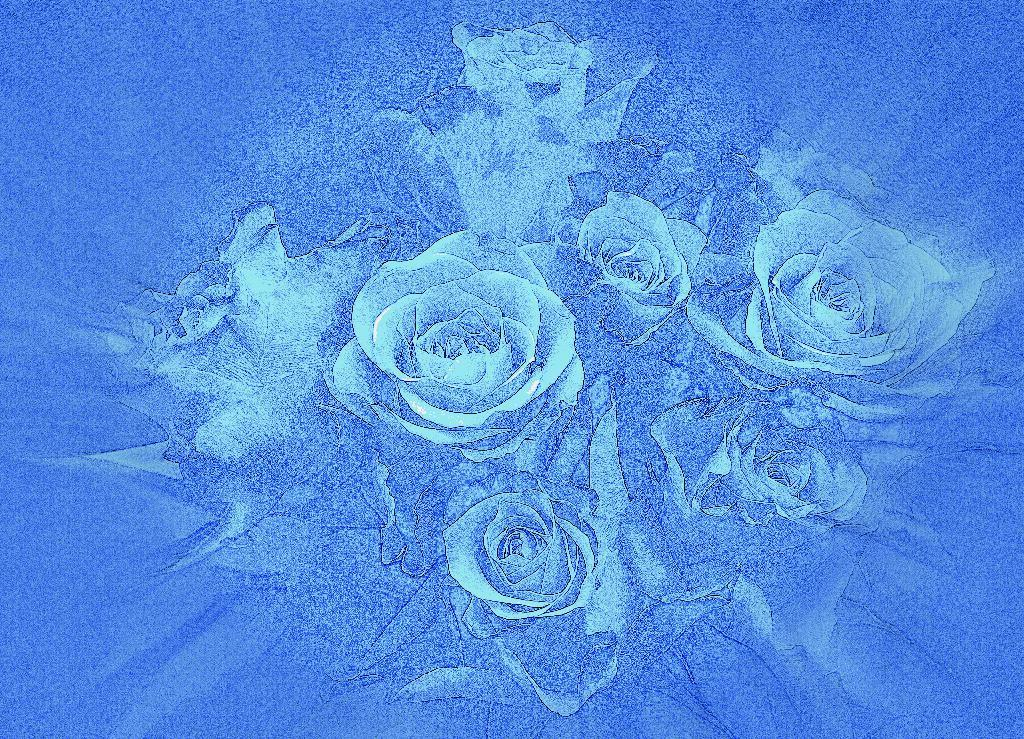What type of image is this? The image is an edited version. What is the main subject of the image? The image depicts roses. What is unique about the roses in the image? The roses are in blue color. What theory does the man in the image propose about the power of roses? There is no man present in the image, and therefore no such theory can be observed. 